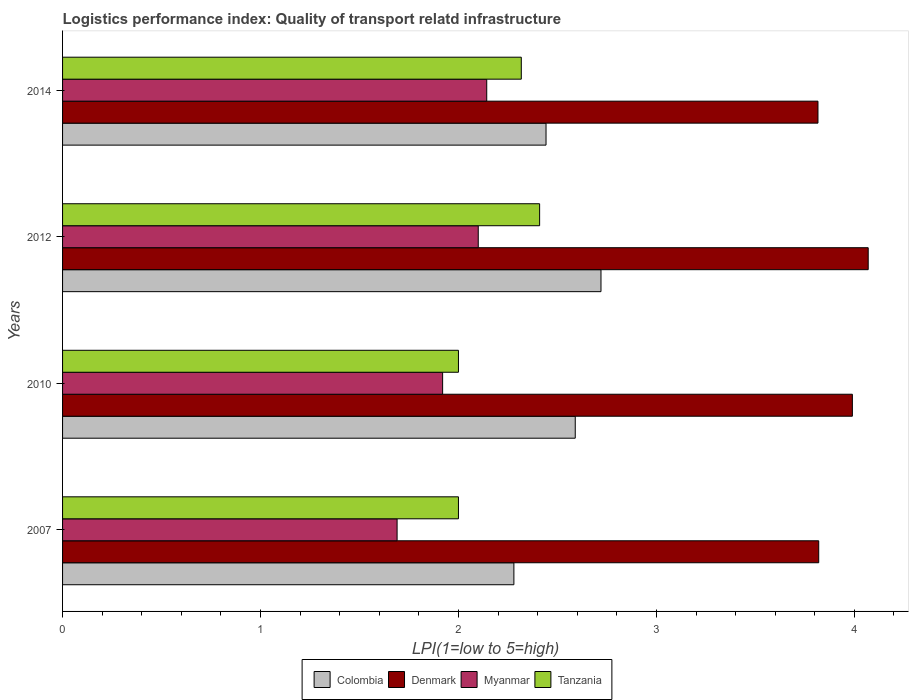How many groups of bars are there?
Your answer should be compact. 4. Are the number of bars per tick equal to the number of legend labels?
Ensure brevity in your answer.  Yes. Are the number of bars on each tick of the Y-axis equal?
Offer a very short reply. Yes. How many bars are there on the 3rd tick from the top?
Your response must be concise. 4. Across all years, what is the maximum logistics performance index in Tanzania?
Provide a short and direct response. 2.41. Across all years, what is the minimum logistics performance index in Myanmar?
Offer a very short reply. 1.69. In which year was the logistics performance index in Tanzania maximum?
Offer a very short reply. 2012. What is the total logistics performance index in Tanzania in the graph?
Offer a very short reply. 8.73. What is the difference between the logistics performance index in Colombia in 2007 and that in 2010?
Give a very brief answer. -0.31. What is the difference between the logistics performance index in Colombia in 2014 and the logistics performance index in Tanzania in 2012?
Ensure brevity in your answer.  0.03. What is the average logistics performance index in Colombia per year?
Provide a succinct answer. 2.51. In the year 2007, what is the difference between the logistics performance index in Colombia and logistics performance index in Myanmar?
Your response must be concise. 0.59. What is the ratio of the logistics performance index in Denmark in 2010 to that in 2012?
Your answer should be very brief. 0.98. What is the difference between the highest and the second highest logistics performance index in Denmark?
Ensure brevity in your answer.  0.08. What is the difference between the highest and the lowest logistics performance index in Colombia?
Your answer should be compact. 0.44. What does the 1st bar from the top in 2014 represents?
Provide a short and direct response. Tanzania. Are all the bars in the graph horizontal?
Make the answer very short. Yes. What is the difference between two consecutive major ticks on the X-axis?
Ensure brevity in your answer.  1. Does the graph contain any zero values?
Offer a very short reply. No. How many legend labels are there?
Ensure brevity in your answer.  4. How are the legend labels stacked?
Ensure brevity in your answer.  Horizontal. What is the title of the graph?
Offer a terse response. Logistics performance index: Quality of transport relatd infrastructure. Does "Kiribati" appear as one of the legend labels in the graph?
Offer a terse response. No. What is the label or title of the X-axis?
Ensure brevity in your answer.  LPI(1=low to 5=high). What is the label or title of the Y-axis?
Provide a short and direct response. Years. What is the LPI(1=low to 5=high) in Colombia in 2007?
Ensure brevity in your answer.  2.28. What is the LPI(1=low to 5=high) in Denmark in 2007?
Provide a succinct answer. 3.82. What is the LPI(1=low to 5=high) in Myanmar in 2007?
Your answer should be compact. 1.69. What is the LPI(1=low to 5=high) in Tanzania in 2007?
Your answer should be very brief. 2. What is the LPI(1=low to 5=high) of Colombia in 2010?
Your answer should be compact. 2.59. What is the LPI(1=low to 5=high) in Denmark in 2010?
Your answer should be very brief. 3.99. What is the LPI(1=low to 5=high) of Myanmar in 2010?
Give a very brief answer. 1.92. What is the LPI(1=low to 5=high) in Colombia in 2012?
Offer a terse response. 2.72. What is the LPI(1=low to 5=high) of Denmark in 2012?
Offer a terse response. 4.07. What is the LPI(1=low to 5=high) in Tanzania in 2012?
Your response must be concise. 2.41. What is the LPI(1=low to 5=high) of Colombia in 2014?
Your answer should be very brief. 2.44. What is the LPI(1=low to 5=high) of Denmark in 2014?
Keep it short and to the point. 3.82. What is the LPI(1=low to 5=high) in Myanmar in 2014?
Your response must be concise. 2.14. What is the LPI(1=low to 5=high) in Tanzania in 2014?
Your answer should be very brief. 2.32. Across all years, what is the maximum LPI(1=low to 5=high) in Colombia?
Keep it short and to the point. 2.72. Across all years, what is the maximum LPI(1=low to 5=high) of Denmark?
Give a very brief answer. 4.07. Across all years, what is the maximum LPI(1=low to 5=high) in Myanmar?
Offer a terse response. 2.14. Across all years, what is the maximum LPI(1=low to 5=high) in Tanzania?
Offer a very short reply. 2.41. Across all years, what is the minimum LPI(1=low to 5=high) in Colombia?
Provide a succinct answer. 2.28. Across all years, what is the minimum LPI(1=low to 5=high) in Denmark?
Keep it short and to the point. 3.82. Across all years, what is the minimum LPI(1=low to 5=high) of Myanmar?
Keep it short and to the point. 1.69. What is the total LPI(1=low to 5=high) of Colombia in the graph?
Make the answer very short. 10.03. What is the total LPI(1=low to 5=high) in Denmark in the graph?
Your answer should be compact. 15.7. What is the total LPI(1=low to 5=high) of Myanmar in the graph?
Give a very brief answer. 7.85. What is the total LPI(1=low to 5=high) of Tanzania in the graph?
Your answer should be compact. 8.73. What is the difference between the LPI(1=low to 5=high) of Colombia in 2007 and that in 2010?
Ensure brevity in your answer.  -0.31. What is the difference between the LPI(1=low to 5=high) in Denmark in 2007 and that in 2010?
Your answer should be compact. -0.17. What is the difference between the LPI(1=low to 5=high) in Myanmar in 2007 and that in 2010?
Ensure brevity in your answer.  -0.23. What is the difference between the LPI(1=low to 5=high) in Colombia in 2007 and that in 2012?
Your answer should be very brief. -0.44. What is the difference between the LPI(1=low to 5=high) in Myanmar in 2007 and that in 2012?
Offer a terse response. -0.41. What is the difference between the LPI(1=low to 5=high) of Tanzania in 2007 and that in 2012?
Provide a succinct answer. -0.41. What is the difference between the LPI(1=low to 5=high) in Colombia in 2007 and that in 2014?
Your answer should be very brief. -0.16. What is the difference between the LPI(1=low to 5=high) of Denmark in 2007 and that in 2014?
Offer a terse response. 0. What is the difference between the LPI(1=low to 5=high) of Myanmar in 2007 and that in 2014?
Offer a very short reply. -0.45. What is the difference between the LPI(1=low to 5=high) of Tanzania in 2007 and that in 2014?
Provide a short and direct response. -0.32. What is the difference between the LPI(1=low to 5=high) in Colombia in 2010 and that in 2012?
Offer a terse response. -0.13. What is the difference between the LPI(1=low to 5=high) in Denmark in 2010 and that in 2012?
Make the answer very short. -0.08. What is the difference between the LPI(1=low to 5=high) of Myanmar in 2010 and that in 2012?
Your response must be concise. -0.18. What is the difference between the LPI(1=low to 5=high) of Tanzania in 2010 and that in 2012?
Your answer should be very brief. -0.41. What is the difference between the LPI(1=low to 5=high) in Colombia in 2010 and that in 2014?
Your response must be concise. 0.15. What is the difference between the LPI(1=low to 5=high) of Denmark in 2010 and that in 2014?
Offer a very short reply. 0.17. What is the difference between the LPI(1=low to 5=high) in Myanmar in 2010 and that in 2014?
Offer a very short reply. -0.22. What is the difference between the LPI(1=low to 5=high) of Tanzania in 2010 and that in 2014?
Give a very brief answer. -0.32. What is the difference between the LPI(1=low to 5=high) in Colombia in 2012 and that in 2014?
Provide a succinct answer. 0.28. What is the difference between the LPI(1=low to 5=high) in Denmark in 2012 and that in 2014?
Your answer should be very brief. 0.25. What is the difference between the LPI(1=low to 5=high) of Myanmar in 2012 and that in 2014?
Give a very brief answer. -0.04. What is the difference between the LPI(1=low to 5=high) of Tanzania in 2012 and that in 2014?
Make the answer very short. 0.09. What is the difference between the LPI(1=low to 5=high) of Colombia in 2007 and the LPI(1=low to 5=high) of Denmark in 2010?
Your answer should be compact. -1.71. What is the difference between the LPI(1=low to 5=high) in Colombia in 2007 and the LPI(1=low to 5=high) in Myanmar in 2010?
Your response must be concise. 0.36. What is the difference between the LPI(1=low to 5=high) in Colombia in 2007 and the LPI(1=low to 5=high) in Tanzania in 2010?
Offer a terse response. 0.28. What is the difference between the LPI(1=low to 5=high) of Denmark in 2007 and the LPI(1=low to 5=high) of Myanmar in 2010?
Make the answer very short. 1.9. What is the difference between the LPI(1=low to 5=high) of Denmark in 2007 and the LPI(1=low to 5=high) of Tanzania in 2010?
Your response must be concise. 1.82. What is the difference between the LPI(1=low to 5=high) of Myanmar in 2007 and the LPI(1=low to 5=high) of Tanzania in 2010?
Your answer should be compact. -0.31. What is the difference between the LPI(1=low to 5=high) in Colombia in 2007 and the LPI(1=low to 5=high) in Denmark in 2012?
Ensure brevity in your answer.  -1.79. What is the difference between the LPI(1=low to 5=high) of Colombia in 2007 and the LPI(1=low to 5=high) of Myanmar in 2012?
Ensure brevity in your answer.  0.18. What is the difference between the LPI(1=low to 5=high) in Colombia in 2007 and the LPI(1=low to 5=high) in Tanzania in 2012?
Provide a succinct answer. -0.13. What is the difference between the LPI(1=low to 5=high) in Denmark in 2007 and the LPI(1=low to 5=high) in Myanmar in 2012?
Your answer should be very brief. 1.72. What is the difference between the LPI(1=low to 5=high) in Denmark in 2007 and the LPI(1=low to 5=high) in Tanzania in 2012?
Keep it short and to the point. 1.41. What is the difference between the LPI(1=low to 5=high) in Myanmar in 2007 and the LPI(1=low to 5=high) in Tanzania in 2012?
Your answer should be very brief. -0.72. What is the difference between the LPI(1=low to 5=high) in Colombia in 2007 and the LPI(1=low to 5=high) in Denmark in 2014?
Offer a very short reply. -1.54. What is the difference between the LPI(1=low to 5=high) in Colombia in 2007 and the LPI(1=low to 5=high) in Myanmar in 2014?
Give a very brief answer. 0.14. What is the difference between the LPI(1=low to 5=high) in Colombia in 2007 and the LPI(1=low to 5=high) in Tanzania in 2014?
Offer a very short reply. -0.04. What is the difference between the LPI(1=low to 5=high) in Denmark in 2007 and the LPI(1=low to 5=high) in Myanmar in 2014?
Make the answer very short. 1.68. What is the difference between the LPI(1=low to 5=high) of Denmark in 2007 and the LPI(1=low to 5=high) of Tanzania in 2014?
Provide a succinct answer. 1.5. What is the difference between the LPI(1=low to 5=high) in Myanmar in 2007 and the LPI(1=low to 5=high) in Tanzania in 2014?
Give a very brief answer. -0.63. What is the difference between the LPI(1=low to 5=high) in Colombia in 2010 and the LPI(1=low to 5=high) in Denmark in 2012?
Give a very brief answer. -1.48. What is the difference between the LPI(1=low to 5=high) in Colombia in 2010 and the LPI(1=low to 5=high) in Myanmar in 2012?
Keep it short and to the point. 0.49. What is the difference between the LPI(1=low to 5=high) of Colombia in 2010 and the LPI(1=low to 5=high) of Tanzania in 2012?
Your answer should be compact. 0.18. What is the difference between the LPI(1=low to 5=high) of Denmark in 2010 and the LPI(1=low to 5=high) of Myanmar in 2012?
Keep it short and to the point. 1.89. What is the difference between the LPI(1=low to 5=high) of Denmark in 2010 and the LPI(1=low to 5=high) of Tanzania in 2012?
Offer a very short reply. 1.58. What is the difference between the LPI(1=low to 5=high) of Myanmar in 2010 and the LPI(1=low to 5=high) of Tanzania in 2012?
Offer a terse response. -0.49. What is the difference between the LPI(1=low to 5=high) of Colombia in 2010 and the LPI(1=low to 5=high) of Denmark in 2014?
Provide a succinct answer. -1.23. What is the difference between the LPI(1=low to 5=high) in Colombia in 2010 and the LPI(1=low to 5=high) in Myanmar in 2014?
Give a very brief answer. 0.45. What is the difference between the LPI(1=low to 5=high) in Colombia in 2010 and the LPI(1=low to 5=high) in Tanzania in 2014?
Make the answer very short. 0.27. What is the difference between the LPI(1=low to 5=high) in Denmark in 2010 and the LPI(1=low to 5=high) in Myanmar in 2014?
Your response must be concise. 1.85. What is the difference between the LPI(1=low to 5=high) of Denmark in 2010 and the LPI(1=low to 5=high) of Tanzania in 2014?
Give a very brief answer. 1.67. What is the difference between the LPI(1=low to 5=high) in Myanmar in 2010 and the LPI(1=low to 5=high) in Tanzania in 2014?
Your answer should be compact. -0.4. What is the difference between the LPI(1=low to 5=high) in Colombia in 2012 and the LPI(1=low to 5=high) in Denmark in 2014?
Keep it short and to the point. -1.1. What is the difference between the LPI(1=low to 5=high) of Colombia in 2012 and the LPI(1=low to 5=high) of Myanmar in 2014?
Ensure brevity in your answer.  0.58. What is the difference between the LPI(1=low to 5=high) of Colombia in 2012 and the LPI(1=low to 5=high) of Tanzania in 2014?
Offer a terse response. 0.4. What is the difference between the LPI(1=low to 5=high) of Denmark in 2012 and the LPI(1=low to 5=high) of Myanmar in 2014?
Your answer should be compact. 1.93. What is the difference between the LPI(1=low to 5=high) in Denmark in 2012 and the LPI(1=low to 5=high) in Tanzania in 2014?
Ensure brevity in your answer.  1.75. What is the difference between the LPI(1=low to 5=high) of Myanmar in 2012 and the LPI(1=low to 5=high) of Tanzania in 2014?
Keep it short and to the point. -0.22. What is the average LPI(1=low to 5=high) in Colombia per year?
Offer a terse response. 2.51. What is the average LPI(1=low to 5=high) in Denmark per year?
Your answer should be compact. 3.92. What is the average LPI(1=low to 5=high) of Myanmar per year?
Provide a short and direct response. 1.96. What is the average LPI(1=low to 5=high) of Tanzania per year?
Offer a terse response. 2.18. In the year 2007, what is the difference between the LPI(1=low to 5=high) of Colombia and LPI(1=low to 5=high) of Denmark?
Provide a short and direct response. -1.54. In the year 2007, what is the difference between the LPI(1=low to 5=high) of Colombia and LPI(1=low to 5=high) of Myanmar?
Give a very brief answer. 0.59. In the year 2007, what is the difference between the LPI(1=low to 5=high) of Colombia and LPI(1=low to 5=high) of Tanzania?
Your answer should be compact. 0.28. In the year 2007, what is the difference between the LPI(1=low to 5=high) in Denmark and LPI(1=low to 5=high) in Myanmar?
Provide a short and direct response. 2.13. In the year 2007, what is the difference between the LPI(1=low to 5=high) in Denmark and LPI(1=low to 5=high) in Tanzania?
Give a very brief answer. 1.82. In the year 2007, what is the difference between the LPI(1=low to 5=high) of Myanmar and LPI(1=low to 5=high) of Tanzania?
Ensure brevity in your answer.  -0.31. In the year 2010, what is the difference between the LPI(1=low to 5=high) in Colombia and LPI(1=low to 5=high) in Myanmar?
Ensure brevity in your answer.  0.67. In the year 2010, what is the difference between the LPI(1=low to 5=high) of Colombia and LPI(1=low to 5=high) of Tanzania?
Keep it short and to the point. 0.59. In the year 2010, what is the difference between the LPI(1=low to 5=high) of Denmark and LPI(1=low to 5=high) of Myanmar?
Ensure brevity in your answer.  2.07. In the year 2010, what is the difference between the LPI(1=low to 5=high) in Denmark and LPI(1=low to 5=high) in Tanzania?
Offer a terse response. 1.99. In the year 2010, what is the difference between the LPI(1=low to 5=high) of Myanmar and LPI(1=low to 5=high) of Tanzania?
Provide a short and direct response. -0.08. In the year 2012, what is the difference between the LPI(1=low to 5=high) in Colombia and LPI(1=low to 5=high) in Denmark?
Keep it short and to the point. -1.35. In the year 2012, what is the difference between the LPI(1=low to 5=high) in Colombia and LPI(1=low to 5=high) in Myanmar?
Your response must be concise. 0.62. In the year 2012, what is the difference between the LPI(1=low to 5=high) in Colombia and LPI(1=low to 5=high) in Tanzania?
Provide a succinct answer. 0.31. In the year 2012, what is the difference between the LPI(1=low to 5=high) in Denmark and LPI(1=low to 5=high) in Myanmar?
Keep it short and to the point. 1.97. In the year 2012, what is the difference between the LPI(1=low to 5=high) in Denmark and LPI(1=low to 5=high) in Tanzania?
Provide a short and direct response. 1.66. In the year 2012, what is the difference between the LPI(1=low to 5=high) of Myanmar and LPI(1=low to 5=high) of Tanzania?
Offer a very short reply. -0.31. In the year 2014, what is the difference between the LPI(1=low to 5=high) in Colombia and LPI(1=low to 5=high) in Denmark?
Give a very brief answer. -1.37. In the year 2014, what is the difference between the LPI(1=low to 5=high) of Colombia and LPI(1=low to 5=high) of Myanmar?
Ensure brevity in your answer.  0.3. In the year 2014, what is the difference between the LPI(1=low to 5=high) in Colombia and LPI(1=low to 5=high) in Tanzania?
Your answer should be compact. 0.12. In the year 2014, what is the difference between the LPI(1=low to 5=high) of Denmark and LPI(1=low to 5=high) of Myanmar?
Your answer should be very brief. 1.67. In the year 2014, what is the difference between the LPI(1=low to 5=high) in Denmark and LPI(1=low to 5=high) in Tanzania?
Your response must be concise. 1.5. In the year 2014, what is the difference between the LPI(1=low to 5=high) in Myanmar and LPI(1=low to 5=high) in Tanzania?
Keep it short and to the point. -0.17. What is the ratio of the LPI(1=low to 5=high) in Colombia in 2007 to that in 2010?
Offer a terse response. 0.88. What is the ratio of the LPI(1=low to 5=high) of Denmark in 2007 to that in 2010?
Your answer should be very brief. 0.96. What is the ratio of the LPI(1=low to 5=high) in Myanmar in 2007 to that in 2010?
Keep it short and to the point. 0.88. What is the ratio of the LPI(1=low to 5=high) of Colombia in 2007 to that in 2012?
Keep it short and to the point. 0.84. What is the ratio of the LPI(1=low to 5=high) of Denmark in 2007 to that in 2012?
Provide a short and direct response. 0.94. What is the ratio of the LPI(1=low to 5=high) of Myanmar in 2007 to that in 2012?
Your response must be concise. 0.8. What is the ratio of the LPI(1=low to 5=high) of Tanzania in 2007 to that in 2012?
Offer a very short reply. 0.83. What is the ratio of the LPI(1=low to 5=high) of Colombia in 2007 to that in 2014?
Give a very brief answer. 0.93. What is the ratio of the LPI(1=low to 5=high) in Denmark in 2007 to that in 2014?
Your answer should be compact. 1. What is the ratio of the LPI(1=low to 5=high) in Myanmar in 2007 to that in 2014?
Make the answer very short. 0.79. What is the ratio of the LPI(1=low to 5=high) of Tanzania in 2007 to that in 2014?
Provide a succinct answer. 0.86. What is the ratio of the LPI(1=low to 5=high) of Colombia in 2010 to that in 2012?
Offer a very short reply. 0.95. What is the ratio of the LPI(1=low to 5=high) of Denmark in 2010 to that in 2012?
Provide a succinct answer. 0.98. What is the ratio of the LPI(1=low to 5=high) of Myanmar in 2010 to that in 2012?
Make the answer very short. 0.91. What is the ratio of the LPI(1=low to 5=high) in Tanzania in 2010 to that in 2012?
Ensure brevity in your answer.  0.83. What is the ratio of the LPI(1=low to 5=high) of Colombia in 2010 to that in 2014?
Give a very brief answer. 1.06. What is the ratio of the LPI(1=low to 5=high) of Denmark in 2010 to that in 2014?
Offer a terse response. 1.05. What is the ratio of the LPI(1=low to 5=high) of Myanmar in 2010 to that in 2014?
Give a very brief answer. 0.9. What is the ratio of the LPI(1=low to 5=high) in Tanzania in 2010 to that in 2014?
Keep it short and to the point. 0.86. What is the ratio of the LPI(1=low to 5=high) of Colombia in 2012 to that in 2014?
Your answer should be very brief. 1.11. What is the ratio of the LPI(1=low to 5=high) of Denmark in 2012 to that in 2014?
Your answer should be very brief. 1.07. What is the ratio of the LPI(1=low to 5=high) in Myanmar in 2012 to that in 2014?
Make the answer very short. 0.98. What is the ratio of the LPI(1=low to 5=high) in Tanzania in 2012 to that in 2014?
Ensure brevity in your answer.  1.04. What is the difference between the highest and the second highest LPI(1=low to 5=high) of Colombia?
Keep it short and to the point. 0.13. What is the difference between the highest and the second highest LPI(1=low to 5=high) of Myanmar?
Your answer should be compact. 0.04. What is the difference between the highest and the second highest LPI(1=low to 5=high) in Tanzania?
Offer a terse response. 0.09. What is the difference between the highest and the lowest LPI(1=low to 5=high) in Colombia?
Your response must be concise. 0.44. What is the difference between the highest and the lowest LPI(1=low to 5=high) in Denmark?
Give a very brief answer. 0.25. What is the difference between the highest and the lowest LPI(1=low to 5=high) in Myanmar?
Offer a very short reply. 0.45. What is the difference between the highest and the lowest LPI(1=low to 5=high) in Tanzania?
Give a very brief answer. 0.41. 